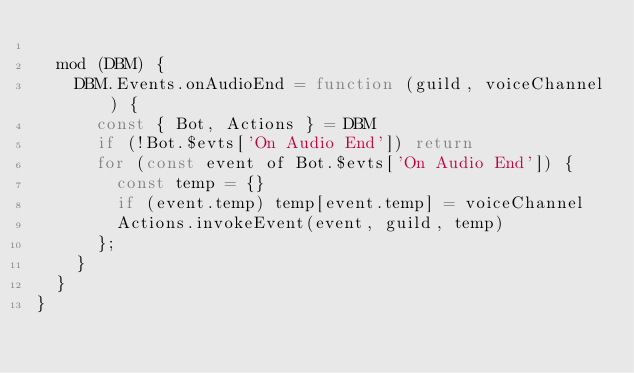<code> <loc_0><loc_0><loc_500><loc_500><_JavaScript_>
  mod (DBM) {
    DBM.Events.onAudioEnd = function (guild, voiceChannel) {
      const { Bot, Actions } = DBM
      if (!Bot.$evts['On Audio End']) return
      for (const event of Bot.$evts['On Audio End']) {
        const temp = {}
        if (event.temp) temp[event.temp] = voiceChannel
        Actions.invokeEvent(event, guild, temp)
      };
    }
  }
}
</code> 